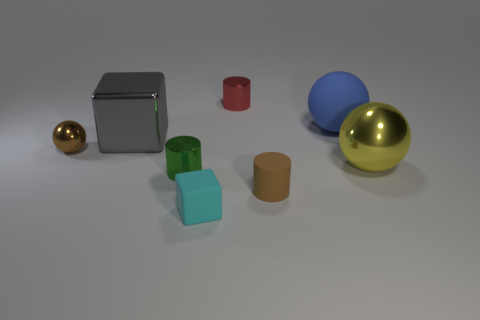Are any small rubber balls visible?
Ensure brevity in your answer.  No. What number of other objects are there of the same size as the yellow thing?
Offer a very short reply. 2. There is a shiny cylinder that is in front of the big yellow metal ball; is it the same color as the object in front of the tiny brown rubber cylinder?
Keep it short and to the point. No. There is another object that is the same shape as the big gray metal object; what size is it?
Provide a short and direct response. Small. Is the material of the large object left of the tiny brown cylinder the same as the cyan object in front of the matte cylinder?
Your answer should be compact. No. How many matte objects are either cubes or blue spheres?
Keep it short and to the point. 2. What material is the gray thing that is on the left side of the tiny matte object that is left of the shiny cylinder that is on the right side of the matte cube?
Offer a terse response. Metal. There is a brown object that is left of the tiny green metal cylinder; is its shape the same as the brown object that is in front of the tiny brown metallic sphere?
Offer a very short reply. No. What color is the tiny metal cylinder on the left side of the shiny cylinder that is to the right of the cyan rubber cube?
Your answer should be very brief. Green. What number of balls are red objects or tiny green shiny objects?
Give a very brief answer. 0. 